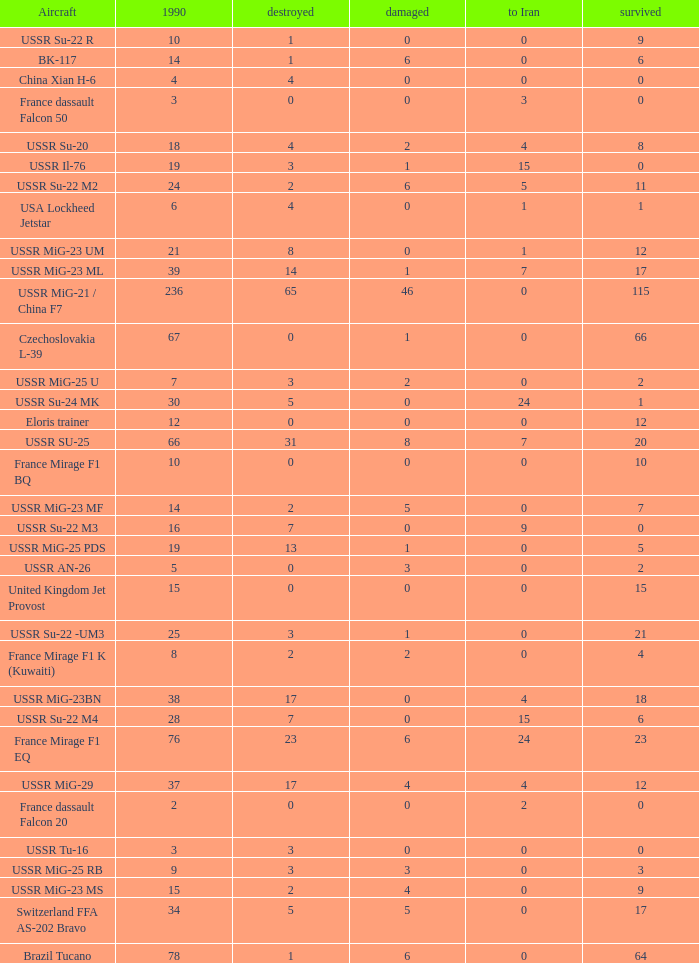If 4 went to iran and the amount that survived was less than 12.0 how many were there in 1990? 1.0. Parse the table in full. {'header': ['Aircraft', '1990', 'destroyed', 'damaged', 'to Iran', 'survived'], 'rows': [['USSR Su-22 R', '10', '1', '0', '0', '9'], ['BK-117', '14', '1', '6', '0', '6'], ['China Xian H-6', '4', '4', '0', '0', '0'], ['France dassault Falcon 50', '3', '0', '0', '3', '0'], ['USSR Su-20', '18', '4', '2', '4', '8'], ['USSR Il-76', '19', '3', '1', '15', '0'], ['USSR Su-22 M2', '24', '2', '6', '5', '11'], ['USA Lockheed Jetstar', '6', '4', '0', '1', '1'], ['USSR MiG-23 UM', '21', '8', '0', '1', '12'], ['USSR MiG-23 ML', '39', '14', '1', '7', '17'], ['USSR MiG-21 / China F7', '236', '65', '46', '0', '115'], ['Czechoslovakia L-39', '67', '0', '1', '0', '66'], ['USSR MiG-25 U', '7', '3', '2', '0', '2'], ['USSR Su-24 MK', '30', '5', '0', '24', '1'], ['Eloris trainer', '12', '0', '0', '0', '12'], ['USSR SU-25', '66', '31', '8', '7', '20'], ['France Mirage F1 BQ', '10', '0', '0', '0', '10'], ['USSR MiG-23 MF', '14', '2', '5', '0', '7'], ['USSR Su-22 M3', '16', '7', '0', '9', '0'], ['USSR MiG-25 PDS', '19', '13', '1', '0', '5'], ['USSR AN-26', '5', '0', '3', '0', '2'], ['United Kingdom Jet Provost', '15', '0', '0', '0', '15'], ['USSR Su-22 -UM3', '25', '3', '1', '0', '21'], ['France Mirage F1 K (Kuwaiti)', '8', '2', '2', '0', '4'], ['USSR MiG-23BN', '38', '17', '0', '4', '18'], ['USSR Su-22 M4', '28', '7', '0', '15', '6'], ['France Mirage F1 EQ', '76', '23', '6', '24', '23'], ['USSR MiG-29', '37', '17', '4', '4', '12'], ['France dassault Falcon 20', '2', '0', '0', '2', '0'], ['USSR Tu-16', '3', '3', '0', '0', '0'], ['USSR MiG-25 RB', '9', '3', '3', '0', '3'], ['USSR MiG-23 MS', '15', '2', '4', '0', '9'], ['Switzerland FFA AS-202 Bravo', '34', '5', '5', '0', '17'], ['Brazil Tucano', '78', '1', '6', '0', '64']]} 